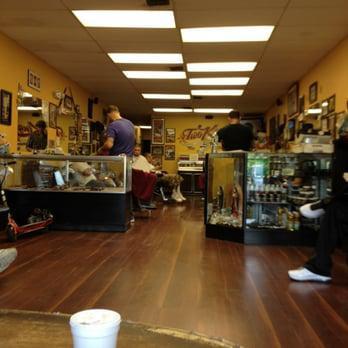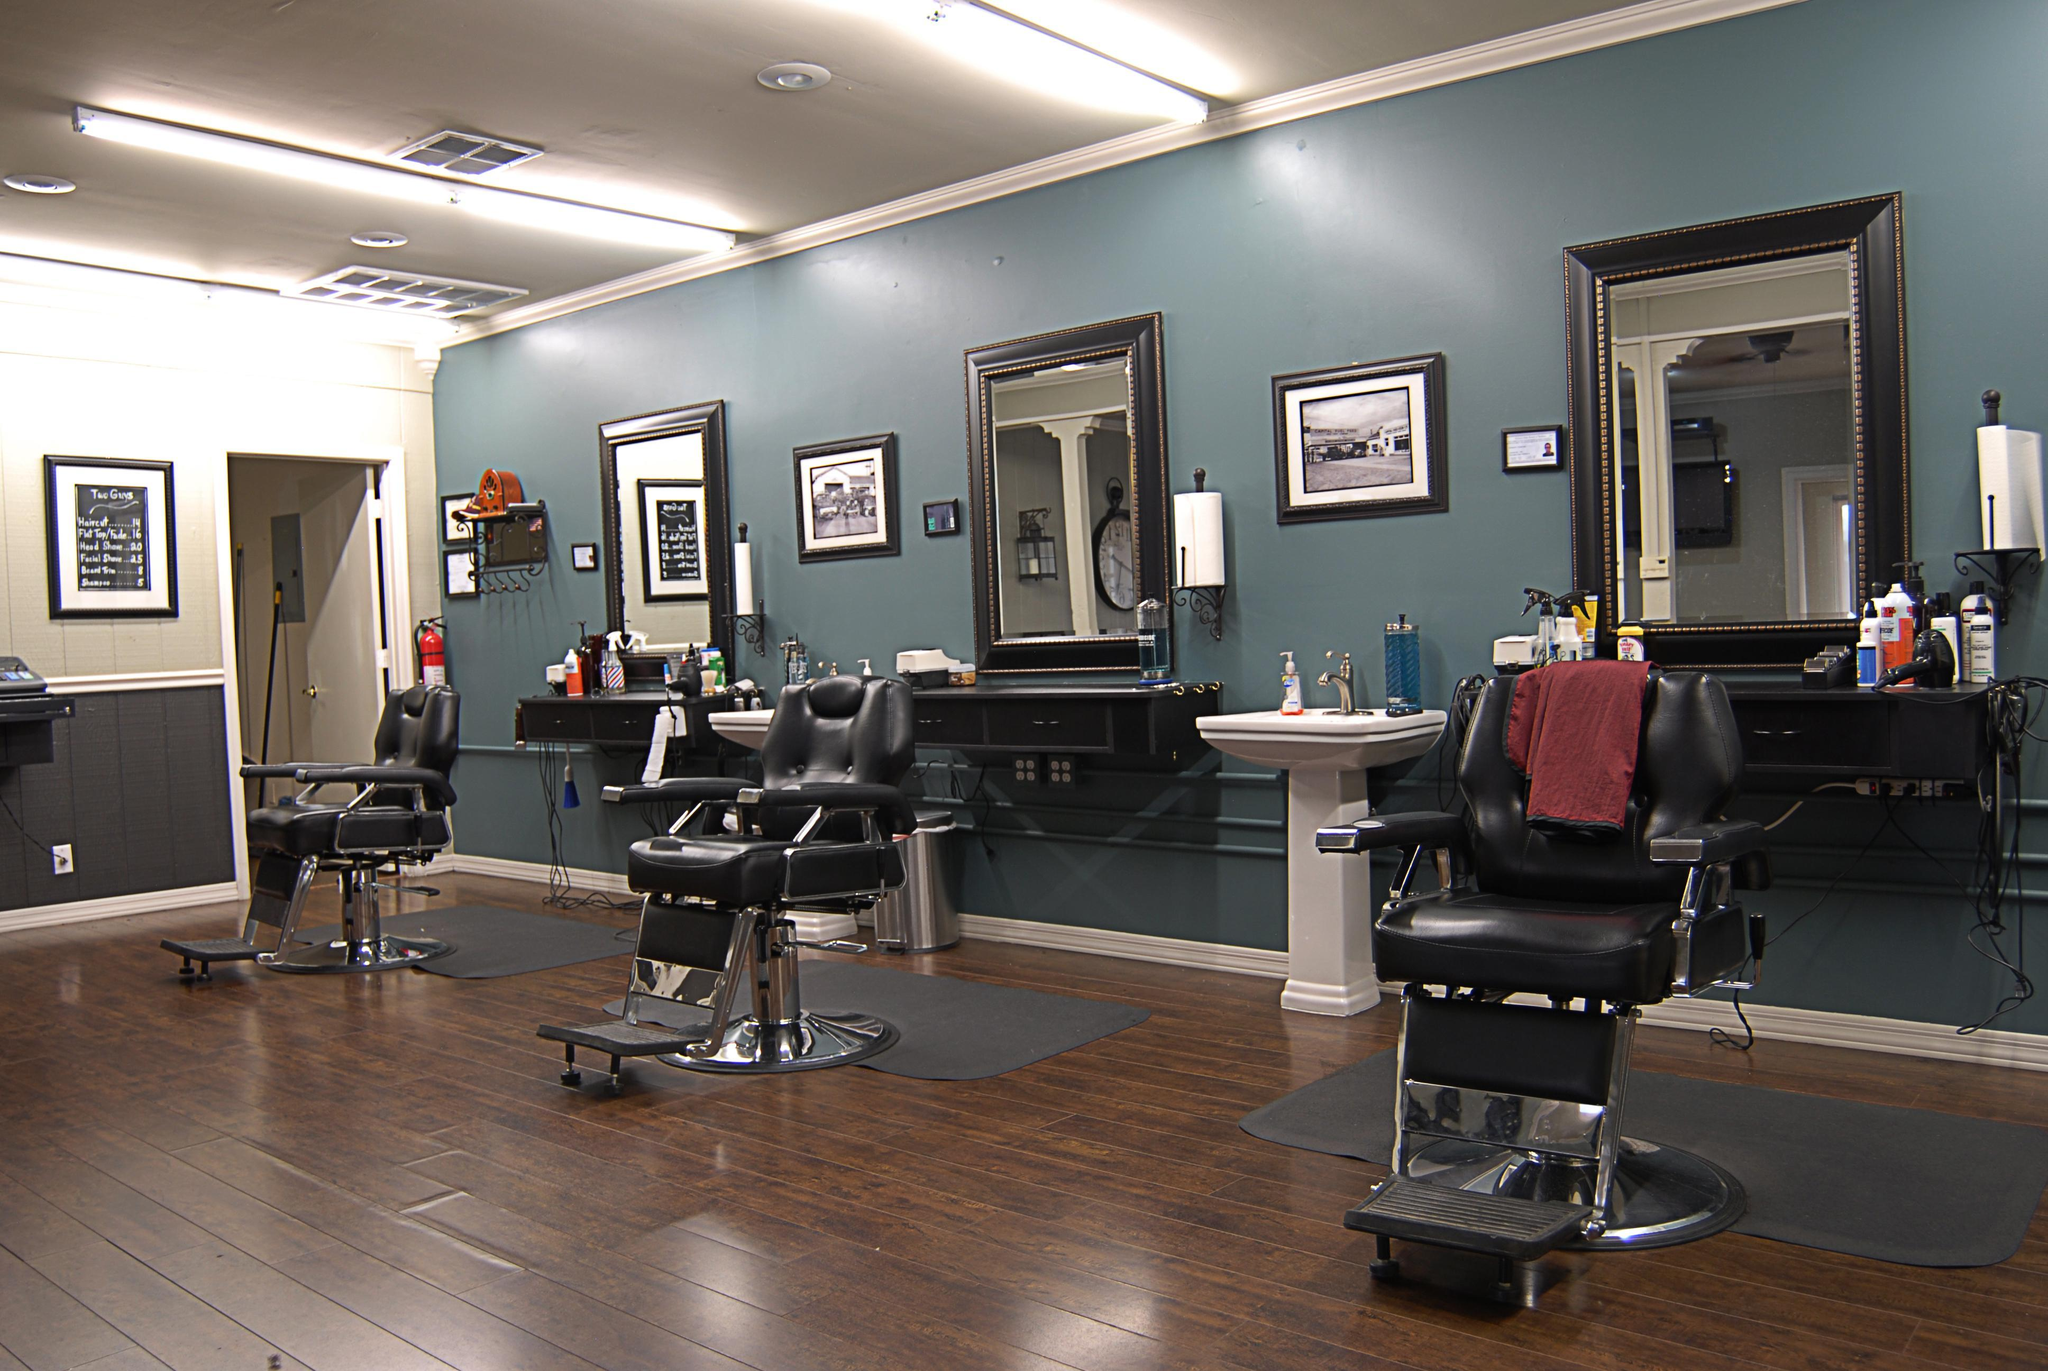The first image is the image on the left, the second image is the image on the right. Considering the images on both sides, is "There are no people visible in the images." valid? Answer yes or no. No. The first image is the image on the left, the second image is the image on the right. Assess this claim about the two images: "there are people in the image on the left". Correct or not? Answer yes or no. Yes. 